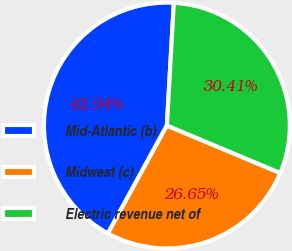<chart> <loc_0><loc_0><loc_500><loc_500><pie_chart><fcel>Mid-Atlantic (b)<fcel>Midwest (c)<fcel>Electric revenue net of<nl><fcel>42.94%<fcel>26.65%<fcel>30.41%<nl></chart> 